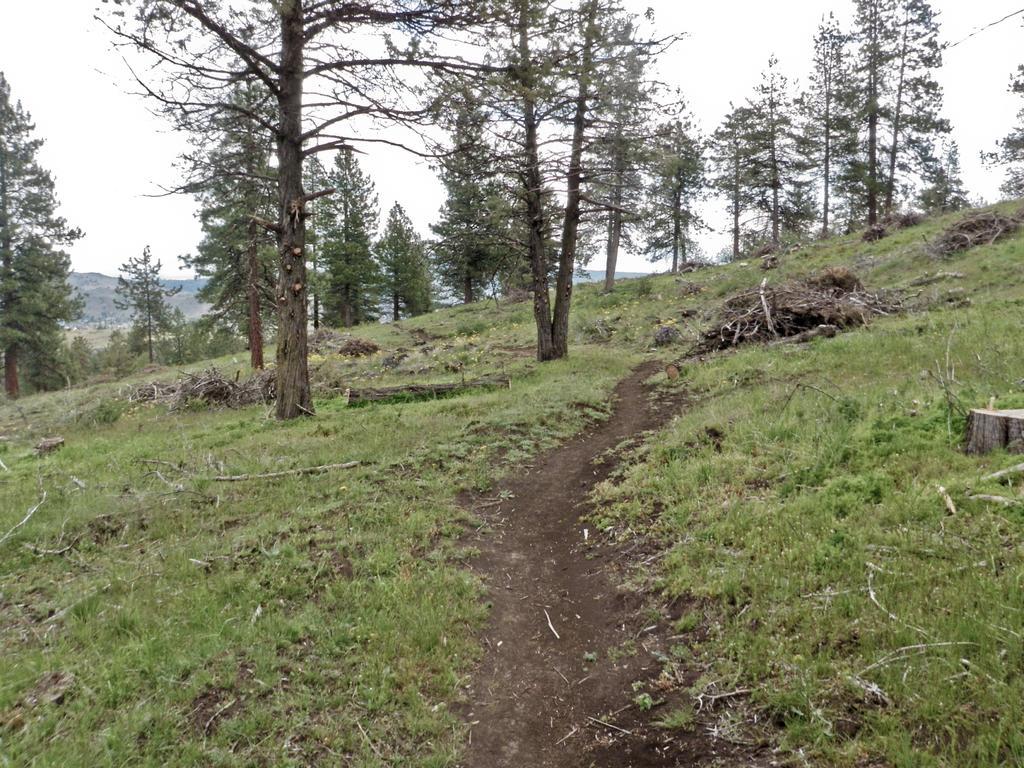Describe this image in one or two sentences. In this image I can see the many trees and I can see the grass on the ground. In the back there are mountains and the white sky. 